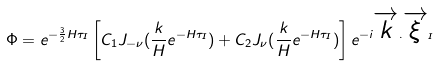<formula> <loc_0><loc_0><loc_500><loc_500>\Phi = e ^ { - \frac { 3 } { 2 } H \tau _ { I } } \left [ C _ { 1 } J _ { - \nu } ( \frac { k } { H } e ^ { - H \tau _ { I } } ) + C _ { 2 } J _ { \nu } ( \frac { k } { H } e ^ { - H \tau _ { I } } ) \right ] e ^ { - i \overrightarrow { k } . \overrightarrow { \xi } _ { I } }</formula> 